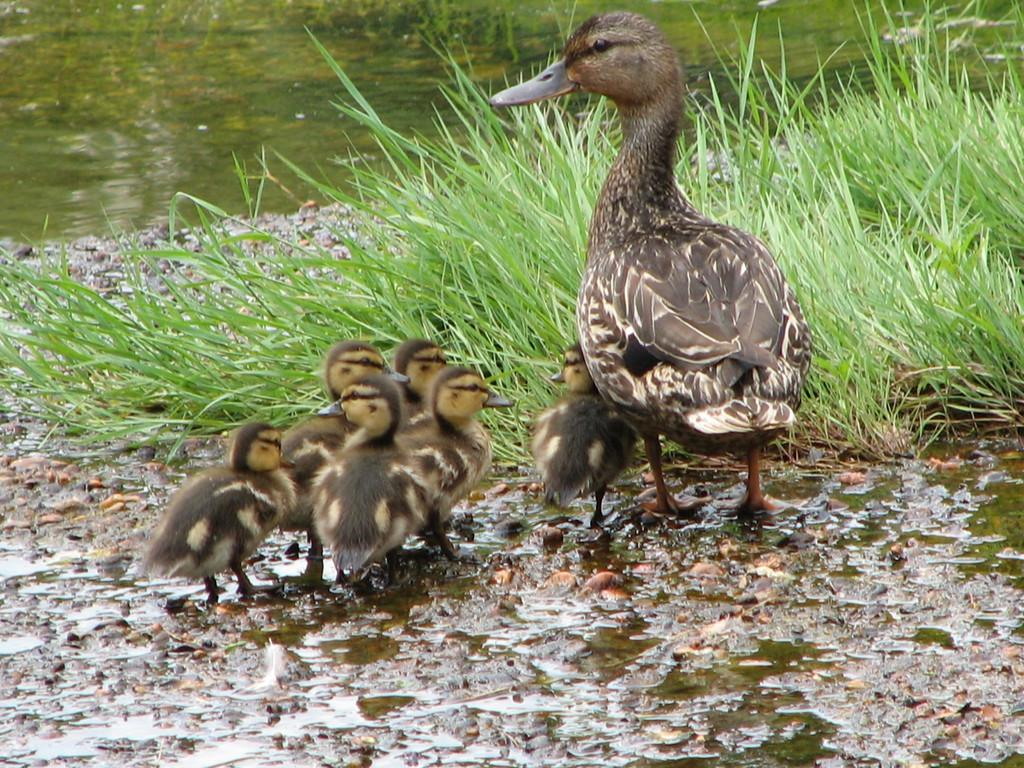What type of body of water is present in the image? There is a lake in the image. What type of terrain surrounds the lake? There is a grassy land in the image. What type of animals can be seen in the image? There are many birds in the image. How many trucks are visible in the image? There are no trucks present in the image. 